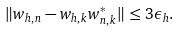<formula> <loc_0><loc_0><loc_500><loc_500>\| w _ { h , n } - w _ { h , k } w ^ { * } _ { n , k } \| \leq 3 \epsilon _ { h } .</formula> 